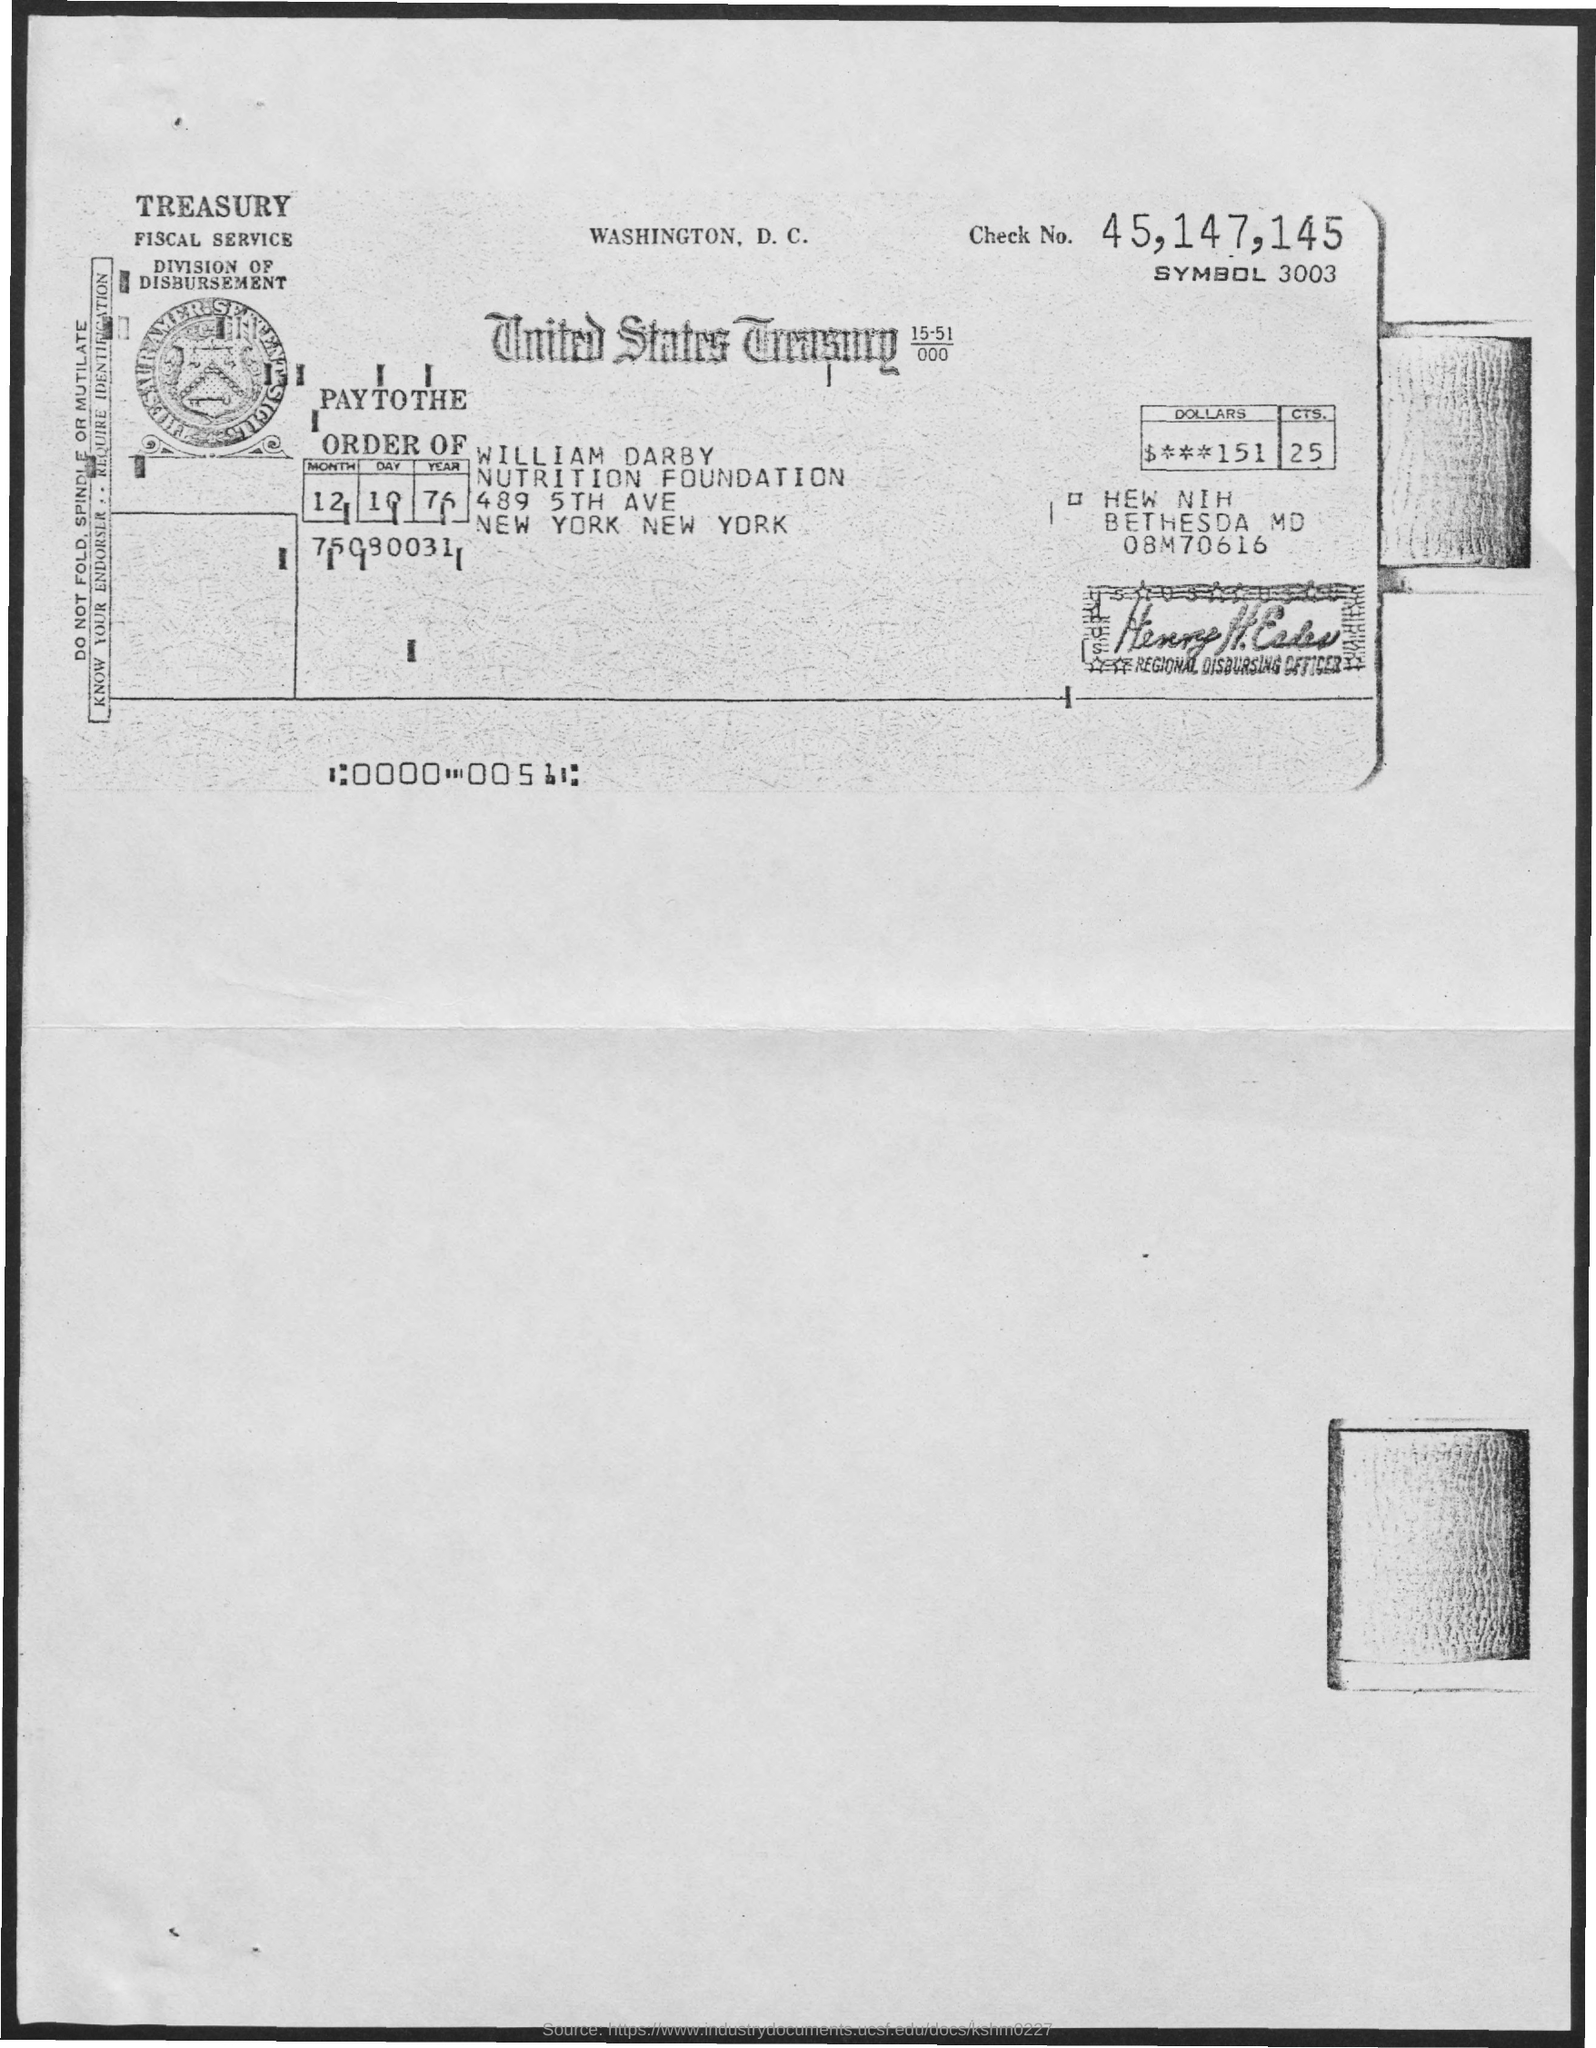Identify some key points in this picture. The check number mentioned is 45, 147, and 145. The amount of dollars mentioned is $151. The Nutrition Foundation is the name of the foundation that I mentioned. The term used to refer to payment made in the order of William Darby is [insert name here]. The name of the division is the division of disbursement. 